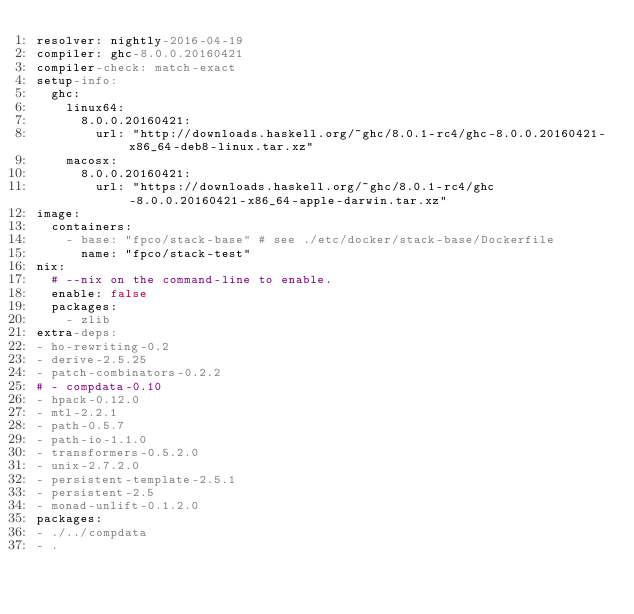<code> <loc_0><loc_0><loc_500><loc_500><_YAML_>resolver: nightly-2016-04-19
compiler: ghc-8.0.0.20160421
compiler-check: match-exact
setup-info:
  ghc:
    linux64:
      8.0.0.20160421:
        url: "http://downloads.haskell.org/~ghc/8.0.1-rc4/ghc-8.0.0.20160421-x86_64-deb8-linux.tar.xz"
    macosx:
      8.0.0.20160421:
        url: "https://downloads.haskell.org/~ghc/8.0.1-rc4/ghc-8.0.0.20160421-x86_64-apple-darwin.tar.xz"
image:
  containers:
    - base: "fpco/stack-base" # see ./etc/docker/stack-base/Dockerfile
      name: "fpco/stack-test"
nix:
  # --nix on the command-line to enable.
  enable: false
  packages:
    - zlib
extra-deps:
- ho-rewriting-0.2
- derive-2.5.25
- patch-combinators-0.2.2
# - compdata-0.10
- hpack-0.12.0
- mtl-2.2.1
- path-0.5.7
- path-io-1.1.0
- transformers-0.5.2.0
- unix-2.7.2.0
- persistent-template-2.5.1
- persistent-2.5
- monad-unlift-0.1.2.0
packages:
- ./../compdata
- .</code> 